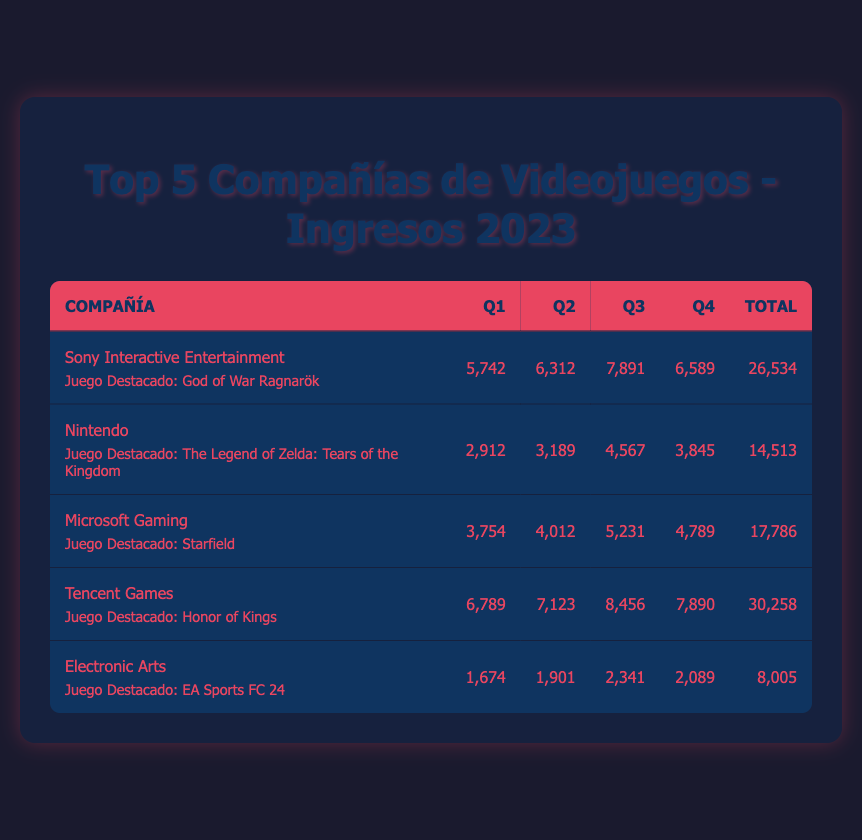¿Cuál fue el total de ingresos de Tencent Games en 2023? Para encontrar el total de ingresos de Tencent Games, sumo los ingresos de cada trimestre: 6,789 + 7,123 + 8,456 + 7,890, lo que da un total de 30,258 millones de USD.
Answer: 30,258 millones de USD ¿Qué compañía tuvo los ingresos más altos en el tercer trimestre de 2023? Al revisar la columna del tercer trimestre, los ingresos son: Sony Interactive Entertainment: 7,891, Nintendo: 4,567, Microsoft Gaming: 5,231, Tencent Games: 8,456, y Electronic Arts: 2,341. El más alto es 8,456 millones de USD de Tencent Games.
Answer: Tencent Games ¿Cuánto más ganó Sony Interactive Entertainment que Electronic Arts en el cuarto trimestre de 2023? Los ingresos de Sony Interactive Entertainment en el cuarto trimestre son 6,589 millones de USD; los de Electronic Arts son 2,089 millones de USD. La diferencia es 6,589 - 2,089 = 4,500 millones de USD.
Answer: 4,500 millones de USD ¿Es cierto que Nintendo tuvo ingresos superiores a 3,000 millones de USD en todos los trimestres de 2023? Revisto los ingresos de Nintendo: Q1: 2,912, Q2: 3,189, Q3: 4,567, y Q4: 3,845. En Q1, no superó 3,000 millones de USD, así que la afirmación es falsa.
Answer: No ¿Cuál es el ingreso promedio trimestral de Microsoft Gaming en 2023? Para calcular el ingreso promedio, sumo los ingresos de Microsoft Gaming en todos los trimestres: 3,754 + 4,012 + 5,231 + 4,789 = 17,786 millones de USD. Luego, divido entre 4 (número de trimestres) para obtener 17,786 / 4 = 4,446.5 millones de USD.
Answer: 4,446.5 millones de USD ¿Cuáles fueron los ingresos totales de las dos compañías con mejores resultados en 2023? Los ingresos totales son: Tencent Games (30,258 millones de USD) y Sony Interactive Entertainment (26,534 millones de USD). Sumo estos valores: 30,258 + 26,534 = 56,792 millones de USD.
Answer: 56,792 millones de USD 